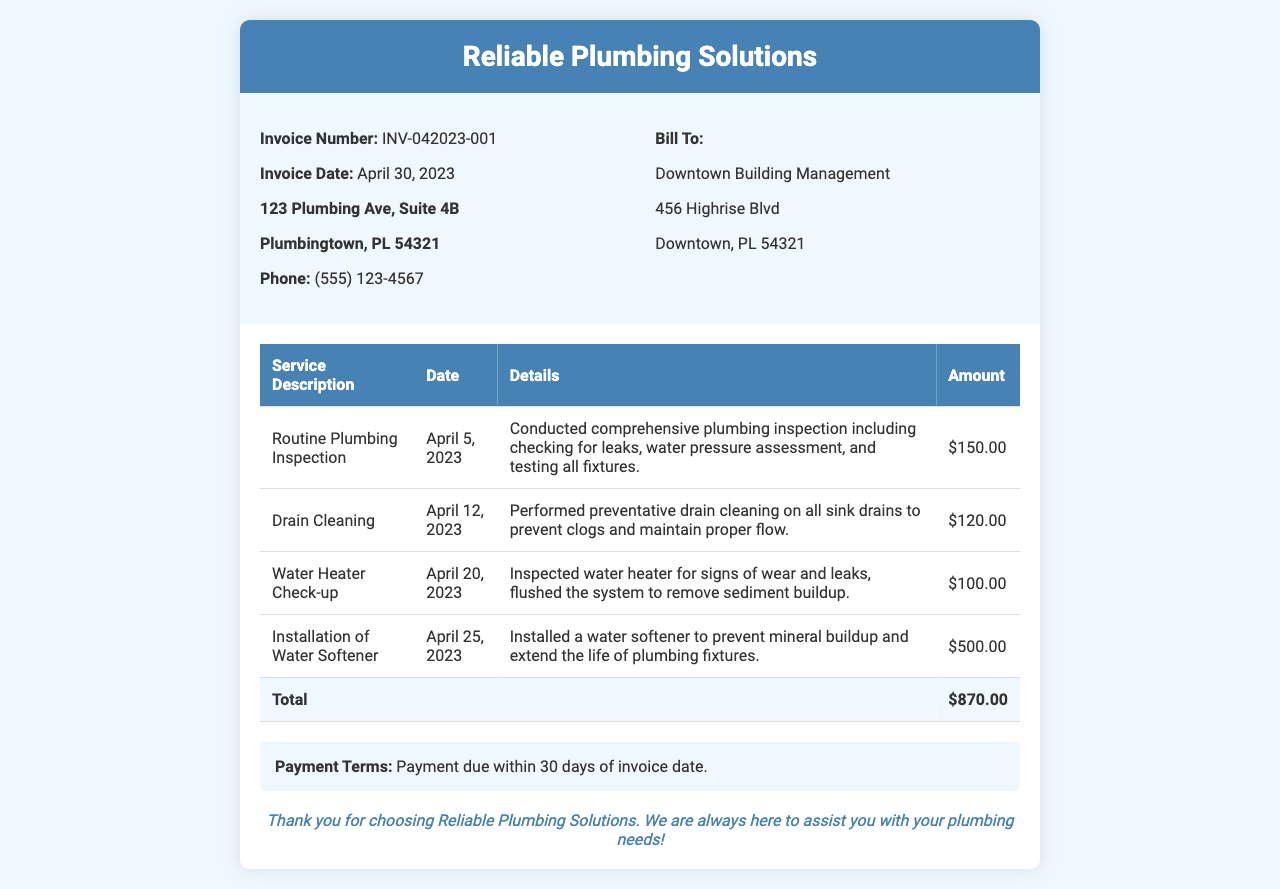What is the invoice number? The invoice number is specified in the document under "Invoice Number," which is used to identify the transaction.
Answer: INV-042023-001 What is the total amount for services rendered? The total amount is calculated from all services listed in the invoice and is found at the bottom of the table under "Total."
Answer: $870.00 When was the routine plumbing inspection performed? The date for the routine plumbing inspection is included in the details of the service rendered.
Answer: April 5, 2023 Who is the invoice billed to? The recipient of the invoice is stated in the "Bill To" section, which identifies who is responsible for payment.
Answer: Downtown Building Management What service was provided on April 20, 2023? The service date correlates to a specific entry in the service table that outlines what was performed on that date.
Answer: Water Heater Check-up What preventative measure was taken during the drain cleaning service? The description of the drain cleaning service explains the action taken to prevent future issues related to plumbing.
Answer: Preventative drain cleaning What is the payment term specified in the invoice? Payment terms are included at the end of the document, outlining the timeframe for payment after the invoice date.
Answer: Payment due within 30 days of invoice date Which service had the highest charge? The costs associated with each service are detailed in the amounts column of the invoice table, allowing identification of the highest charge.
Answer: Installation of Water Softener What is the invoice date? The date of the invoice is listed clearly in the document, which indicates when the invoice was issued.
Answer: April 30, 2023 